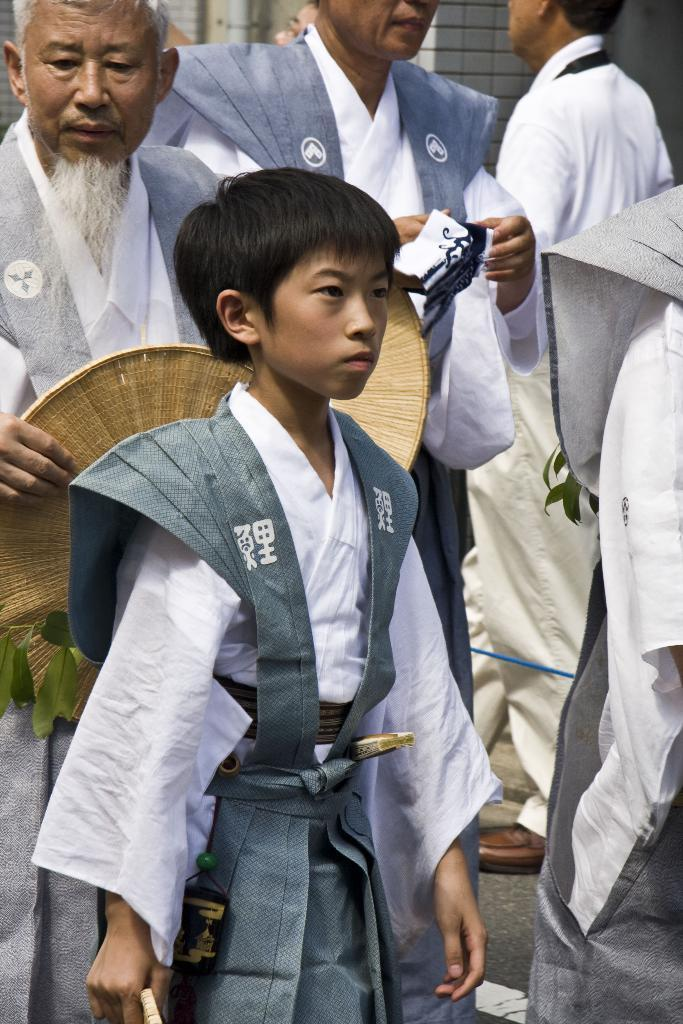Who is present in the image? There are people in the image. What is the man holding in the image? The man is holding a wooden object. What type of vegetation can be seen in the image? Leaves are visible in the image. What can be seen in the background of the image? There is a wall in the background of the image. What type of sign can be seen hanging from the wall in the image? There is no sign visible in the image; only leaves, a wall, and people are present. Can you tell me how many pears are on the wooden object held by the man? There are no pears present in the image; the man is holding a wooden object, but no fruits are visible. 